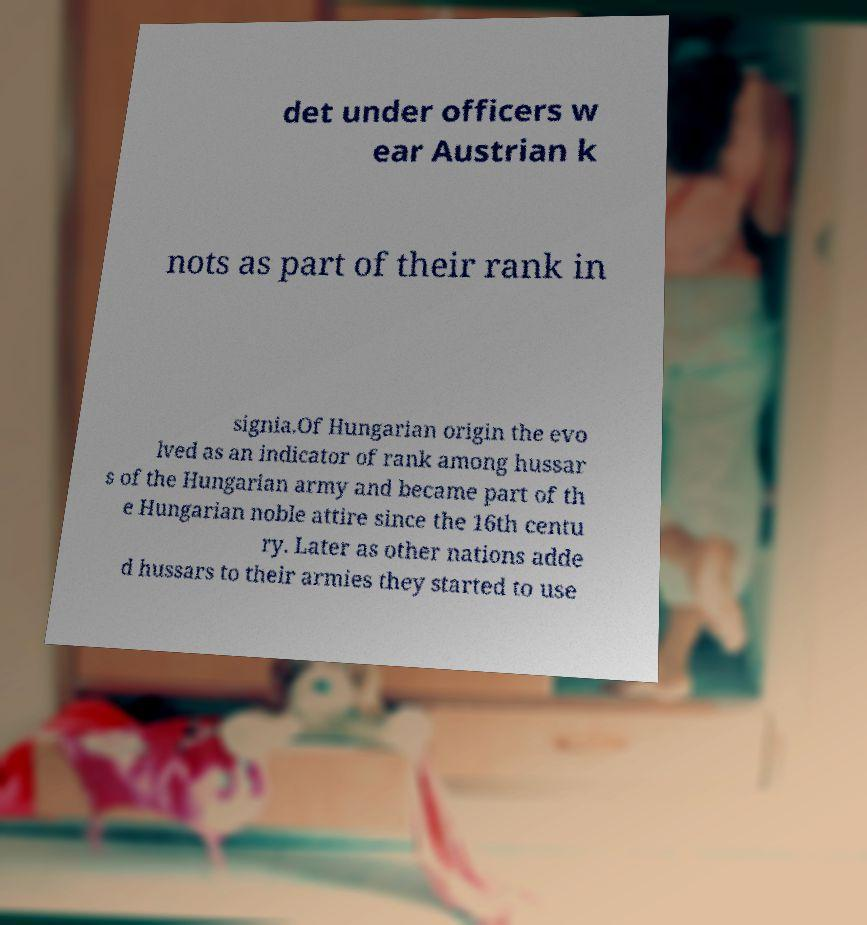Please identify and transcribe the text found in this image. det under officers w ear Austrian k nots as part of their rank in signia.Of Hungarian origin the evo lved as an indicator of rank among hussar s of the Hungarian army and became part of th e Hungarian noble attire since the 16th centu ry. Later as other nations adde d hussars to their armies they started to use 